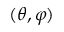<formula> <loc_0><loc_0><loc_500><loc_500>( \theta , \varphi )</formula> 